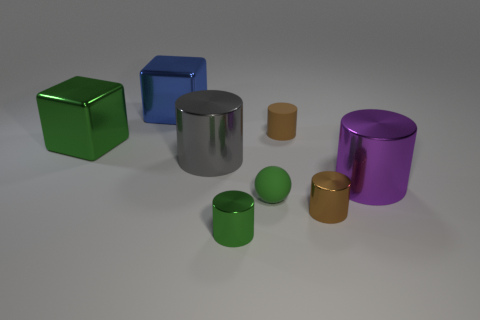Subtract all purple metallic cylinders. How many cylinders are left? 4 Subtract all gray cylinders. How many cylinders are left? 4 Subtract all cyan cylinders. Subtract all yellow cubes. How many cylinders are left? 5 Add 1 tiny green things. How many objects exist? 9 Subtract all cylinders. How many objects are left? 3 Subtract all blocks. Subtract all purple cylinders. How many objects are left? 5 Add 3 large shiny cylinders. How many large shiny cylinders are left? 5 Add 2 small balls. How many small balls exist? 3 Subtract 0 cyan blocks. How many objects are left? 8 